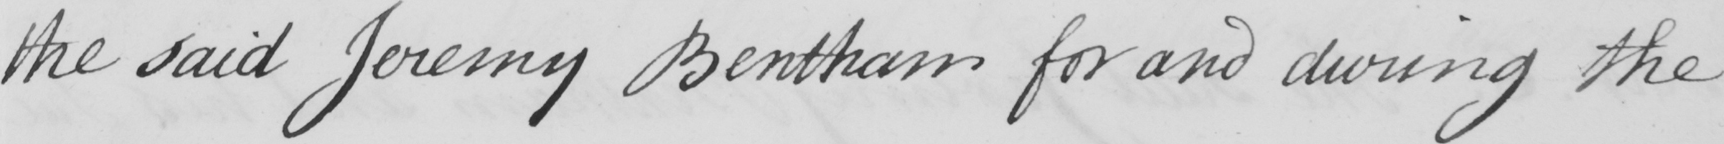Transcribe the text shown in this historical manuscript line. the said Jeremy Bentham for and during the 